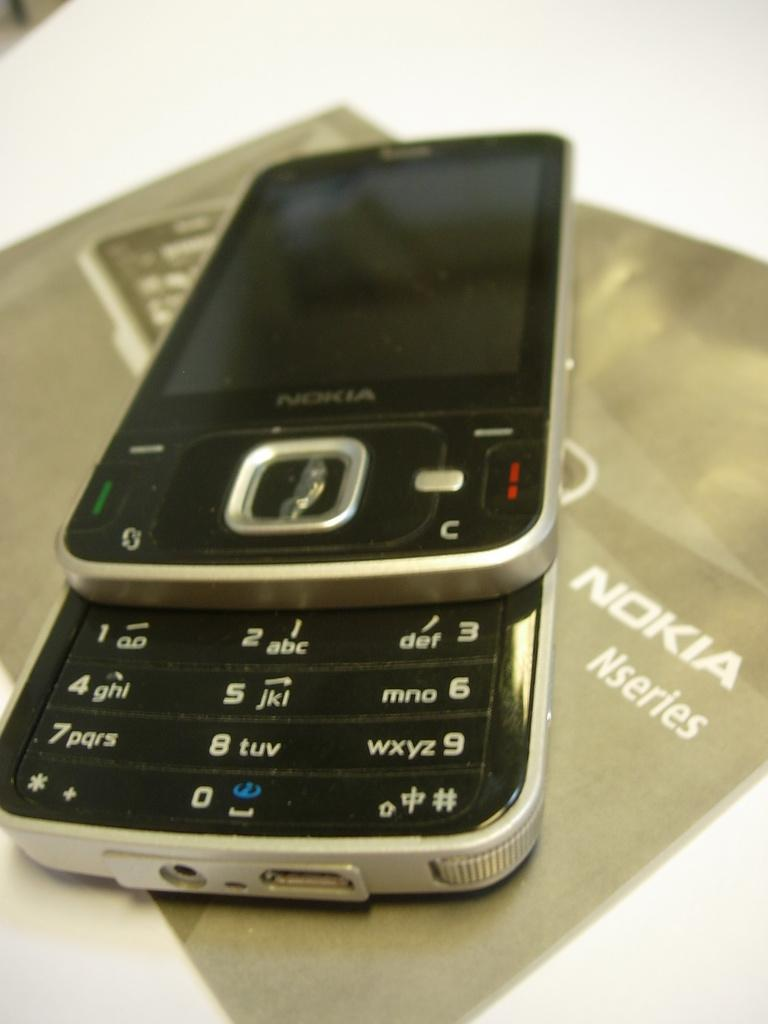Provide a one-sentence caption for the provided image. A close up of an old style sliding Nokia Nseries phone. 